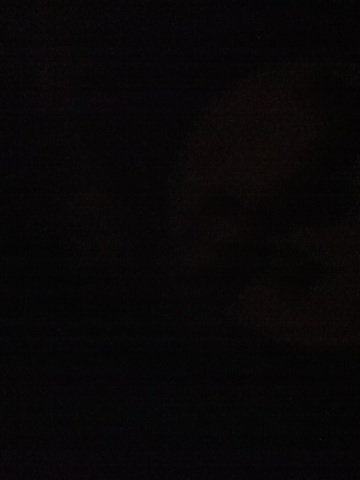This image seems serene. Can you describe a peaceful scenario related to it? The enveloping darkness imparts a sense of tranquility, reminiscent of a calm night away from the bustling city. Perhaps it is a secluded forest clearing under a new moon, where the only sounds are the gentle rustling of leaves and the distant call of nocturnal creatures. This serene solitude offers a perfect place for quiet reflection and rest.  Judging by the darkness, can you imagine a realistic event taking place in this scene? Considering the profound darkness, it might be a scene during a power outage in a city, where the usual brilliance of streetlights and buildings is replaced by the faint glow of an emergency lantern or the occasional flicker of candlelight from residential windows. People move cautiously, navigating their way with flashlights or mobile phones, making an otherwise familiar environment appear mysterious and intriguing. 